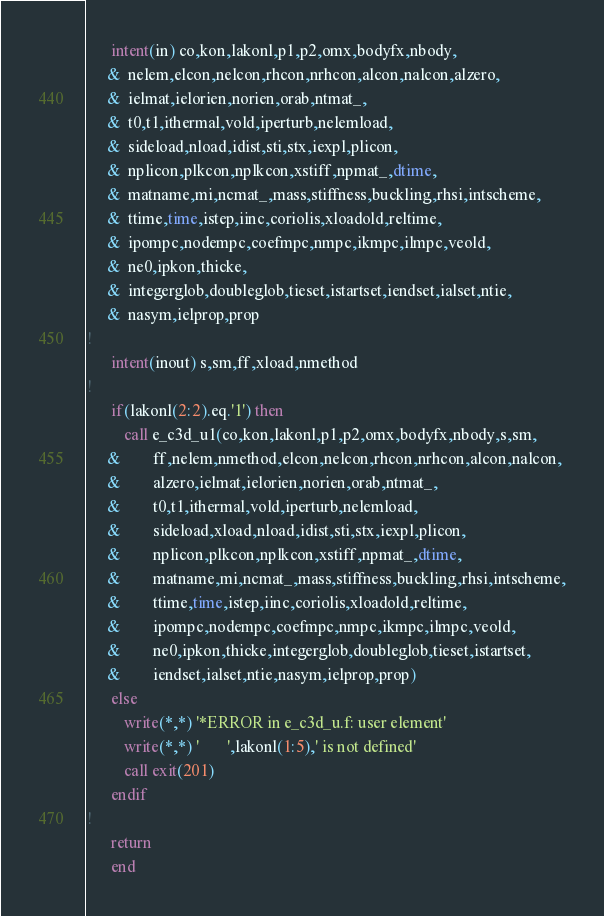Convert code to text. <code><loc_0><loc_0><loc_500><loc_500><_FORTRAN_>      intent(in) co,kon,lakonl,p1,p2,omx,bodyfx,nbody,
     &  nelem,elcon,nelcon,rhcon,nrhcon,alcon,nalcon,alzero,
     &  ielmat,ielorien,norien,orab,ntmat_,
     &  t0,t1,ithermal,vold,iperturb,nelemload,
     &  sideload,nload,idist,sti,stx,iexpl,plicon,
     &  nplicon,plkcon,nplkcon,xstiff,npmat_,dtime,
     &  matname,mi,ncmat_,mass,stiffness,buckling,rhsi,intscheme,
     &  ttime,time,istep,iinc,coriolis,xloadold,reltime,
     &  ipompc,nodempc,coefmpc,nmpc,ikmpc,ilmpc,veold,
     &  ne0,ipkon,thicke,
     &  integerglob,doubleglob,tieset,istartset,iendset,ialset,ntie,
     &  nasym,ielprop,prop
!
      intent(inout) s,sm,ff,xload,nmethod
!
      if(lakonl(2:2).eq.'1') then
         call e_c3d_u1(co,kon,lakonl,p1,p2,omx,bodyfx,nbody,s,sm,
     &        ff,nelem,nmethod,elcon,nelcon,rhcon,nrhcon,alcon,nalcon,
     &        alzero,ielmat,ielorien,norien,orab,ntmat_,
     &        t0,t1,ithermal,vold,iperturb,nelemload,
     &        sideload,xload,nload,idist,sti,stx,iexpl,plicon,
     &        nplicon,plkcon,nplkcon,xstiff,npmat_,dtime,
     &        matname,mi,ncmat_,mass,stiffness,buckling,rhsi,intscheme,
     &        ttime,time,istep,iinc,coriolis,xloadold,reltime,
     &        ipompc,nodempc,coefmpc,nmpc,ikmpc,ilmpc,veold,
     &        ne0,ipkon,thicke,integerglob,doubleglob,tieset,istartset,
     &        iendset,ialset,ntie,nasym,ielprop,prop)
      else
         write(*,*) '*ERROR in e_c3d_u.f: user element'
         write(*,*) '       ',lakonl(1:5),' is not defined'
         call exit(201)
      endif
!     
      return
      end

</code> 